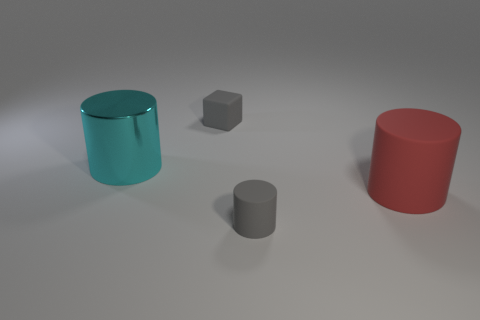There is a cube that is the same color as the small cylinder; what is its size?
Give a very brief answer. Small. There is a thing that is the same color as the small rubber cylinder; what is its material?
Offer a terse response. Rubber. Are there fewer tiny gray matte objects right of the small cylinder than rubber cubes that are in front of the metal cylinder?
Your response must be concise. No. What number of things are either rubber objects that are in front of the large metallic cylinder or gray matte blocks?
Make the answer very short. 3. The gray object to the left of the tiny matte cylinder that is to the right of the large metal object is what shape?
Your answer should be compact. Cube. Is there a matte cylinder that has the same size as the matte cube?
Provide a succinct answer. Yes. Is the number of large cyan cylinders greater than the number of big brown matte cubes?
Provide a short and direct response. Yes. Is the size of the cylinder that is to the right of the tiny rubber cylinder the same as the gray thing on the left side of the small matte cylinder?
Your answer should be very brief. No. What number of matte objects are right of the tiny cube and to the left of the red cylinder?
Make the answer very short. 1. There is another metal thing that is the same shape as the large red object; what color is it?
Your response must be concise. Cyan. 